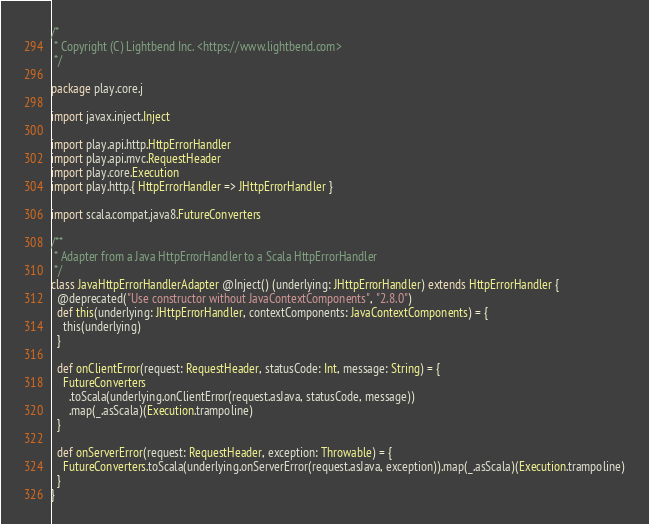<code> <loc_0><loc_0><loc_500><loc_500><_Scala_>/*
 * Copyright (C) Lightbend Inc. <https://www.lightbend.com>
 */

package play.core.j

import javax.inject.Inject

import play.api.http.HttpErrorHandler
import play.api.mvc.RequestHeader
import play.core.Execution
import play.http.{ HttpErrorHandler => JHttpErrorHandler }

import scala.compat.java8.FutureConverters

/**
 * Adapter from a Java HttpErrorHandler to a Scala HttpErrorHandler
 */
class JavaHttpErrorHandlerAdapter @Inject() (underlying: JHttpErrorHandler) extends HttpErrorHandler {
  @deprecated("Use constructor without JavaContextComponents", "2.8.0")
  def this(underlying: JHttpErrorHandler, contextComponents: JavaContextComponents) = {
    this(underlying)
  }

  def onClientError(request: RequestHeader, statusCode: Int, message: String) = {
    FutureConverters
      .toScala(underlying.onClientError(request.asJava, statusCode, message))
      .map(_.asScala)(Execution.trampoline)
  }

  def onServerError(request: RequestHeader, exception: Throwable) = {
    FutureConverters.toScala(underlying.onServerError(request.asJava, exception)).map(_.asScala)(Execution.trampoline)
  }
}
</code> 